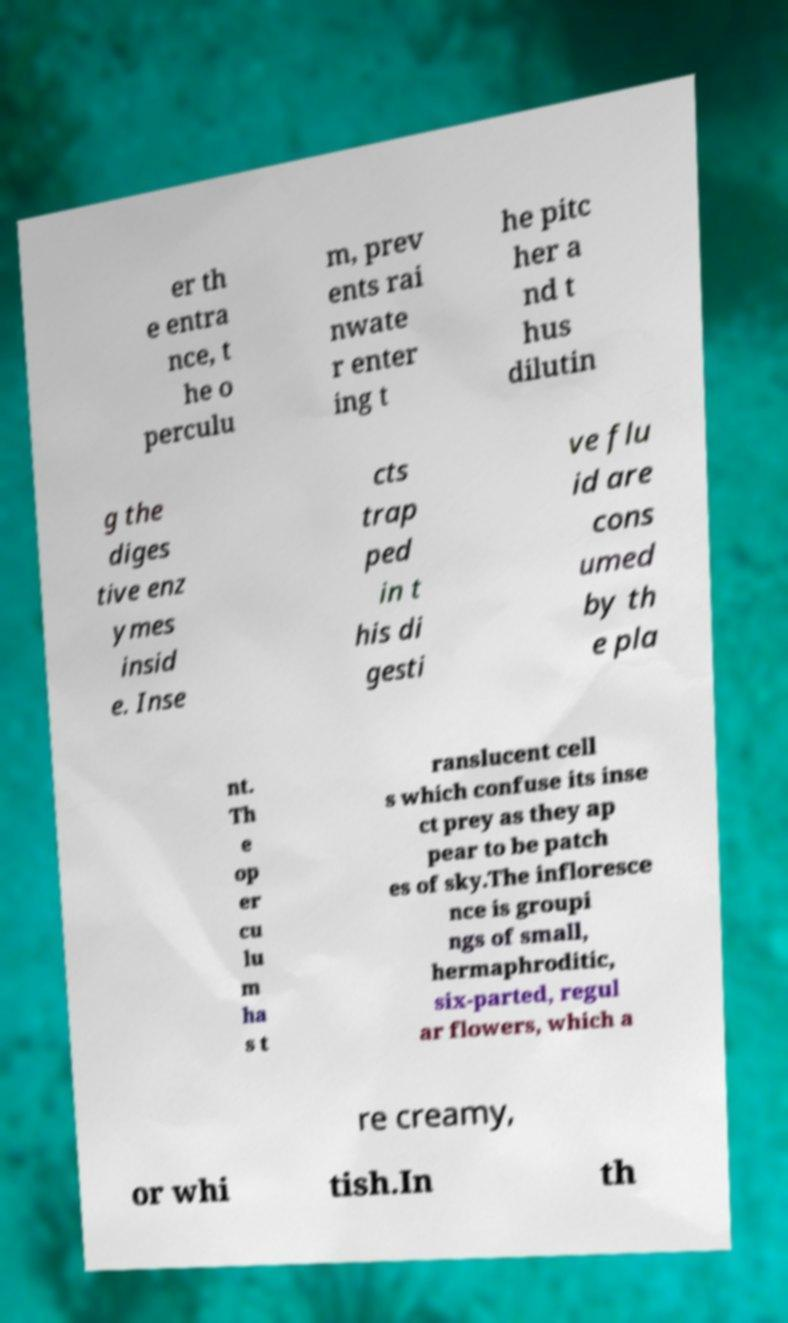Please identify and transcribe the text found in this image. er th e entra nce, t he o perculu m, prev ents rai nwate r enter ing t he pitc her a nd t hus dilutin g the diges tive enz ymes insid e. Inse cts trap ped in t his di gesti ve flu id are cons umed by th e pla nt. Th e op er cu lu m ha s t ranslucent cell s which confuse its inse ct prey as they ap pear to be patch es of sky.The infloresce nce is groupi ngs of small, hermaphroditic, six-parted, regul ar flowers, which a re creamy, or whi tish.In th 